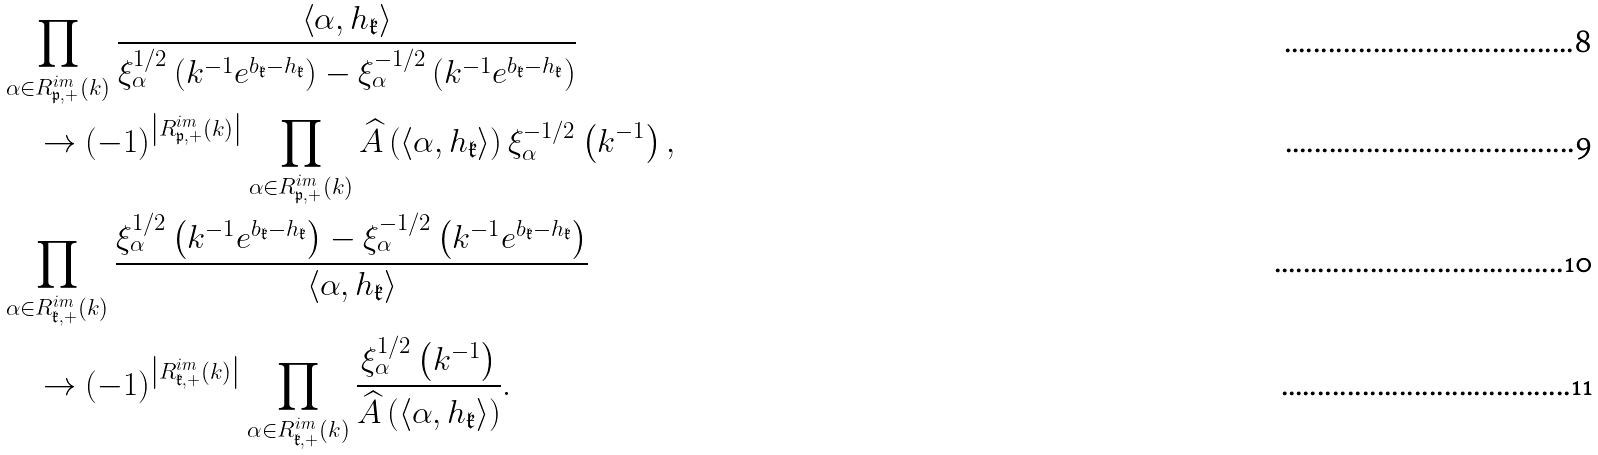<formula> <loc_0><loc_0><loc_500><loc_500>& \prod _ { \alpha \in R ^ { i m } _ { \mathfrak p , + } \left ( k \right ) } \frac { \left \langle \alpha , h _ { \mathfrak k } \right \rangle } { \xi _ { \alpha } ^ { 1 / 2 } \left ( k ^ { - 1 } e ^ { b _ { \mathfrak k } - h _ { \mathfrak k } } \right ) - \xi _ { \alpha } ^ { - 1 / 2 } \left ( k ^ { - 1 } e ^ { b _ { \mathfrak k } - h _ { \mathfrak k } } \right ) } \\ & \quad \to \left ( - 1 \right ) ^ { \left | R _ { \mathfrak p , + } ^ { i m } \left ( k \right ) \right | } \prod _ { \alpha \in R ^ { i m } _ { \mathfrak p , + } \left ( k \right ) } \widehat { A } \left ( \left \langle \alpha , h _ { \mathfrak k } \right \rangle \right ) \xi _ { \alpha } ^ { - 1 / 2 } \left ( k ^ { - 1 } \right ) , \\ & \prod _ { \alpha \in R ^ { i m } _ { \mathfrak k , + } \left ( k \right ) } \frac { \xi _ { \alpha } ^ { 1 / 2 } \left ( k ^ { - 1 } e ^ { b _ { \mathfrak k } - h _ { \mathfrak k } } \right ) - \xi _ { \alpha } ^ { - 1 / 2 } \left ( k ^ { - 1 } e ^ { b _ { \mathfrak k } - h _ { \mathfrak k } } \right ) } { \left \langle \alpha , h _ { \mathfrak k } \right \rangle } \\ & \quad \to \left ( - 1 \right ) ^ { \left | R ^ { i m } _ { \mathfrak k , + } \left ( k \right ) \right | } \prod _ { \alpha \in R ^ { i m } _ { \mathfrak k , + } \left ( k \right ) } \frac { \xi _ { \alpha } ^ { 1 / 2 } \left ( k ^ { - 1 } \right ) } { \widehat { A } \left ( \left \langle \alpha , h _ { \mathfrak k } \right \rangle \right ) } .</formula> 